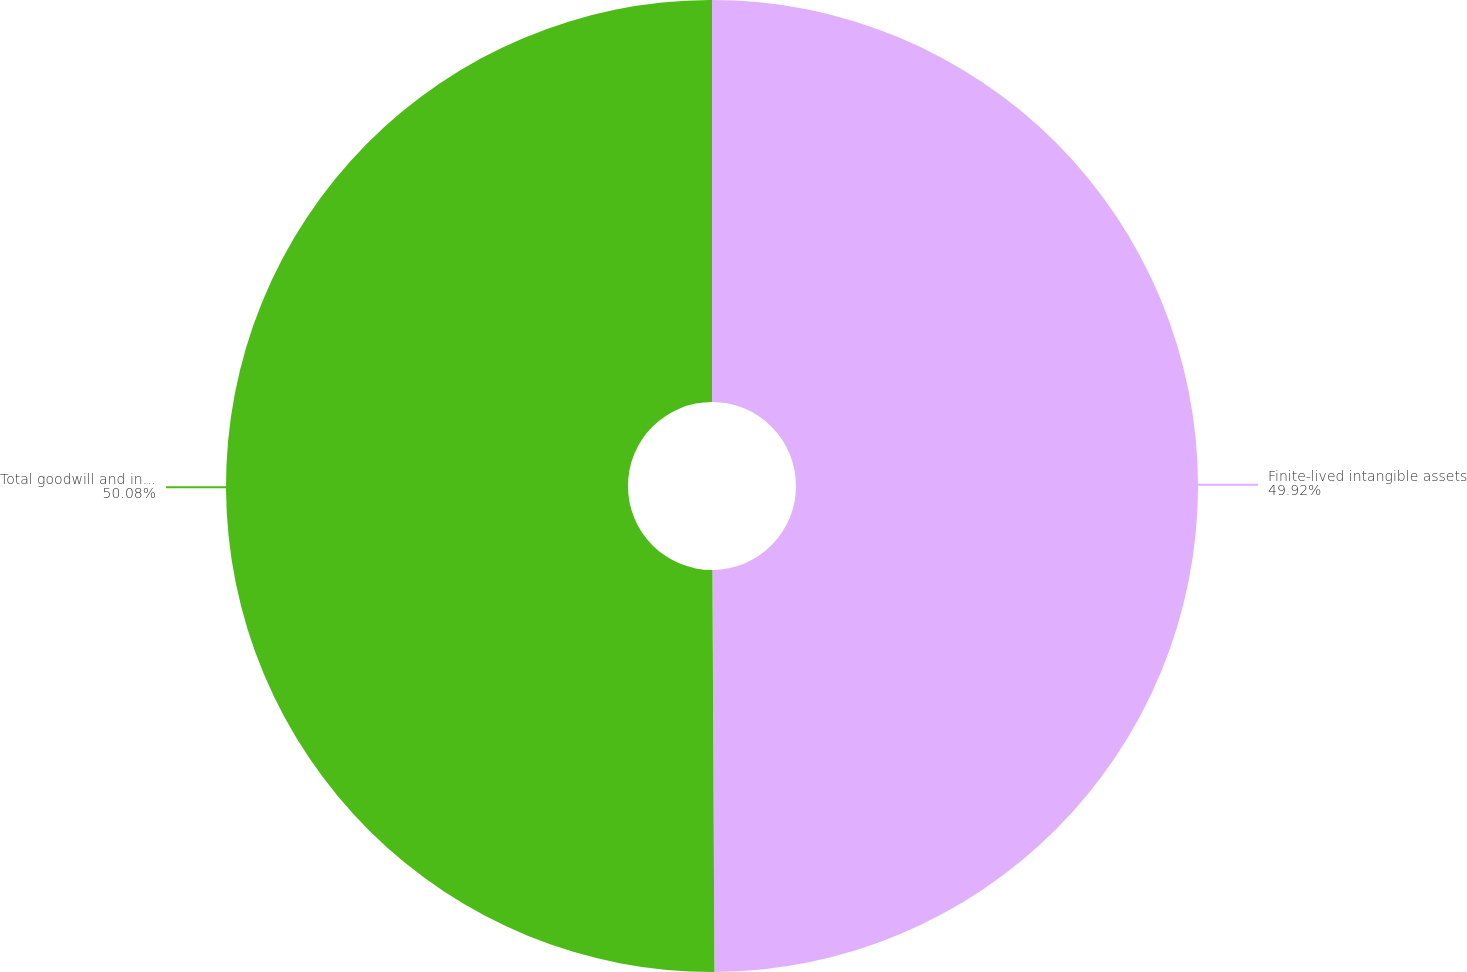Convert chart to OTSL. <chart><loc_0><loc_0><loc_500><loc_500><pie_chart><fcel>Finite-lived intangible assets<fcel>Total goodwill and intangible<nl><fcel>49.92%<fcel>50.08%<nl></chart> 